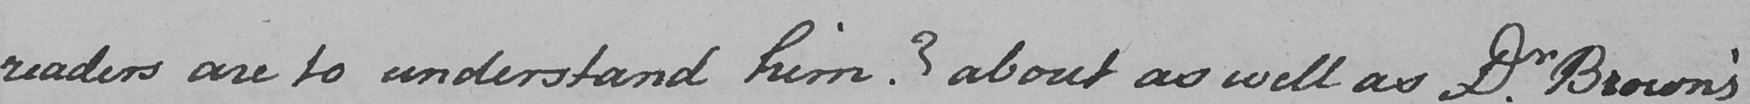Please transcribe the handwritten text in this image. readers are to understand him ?  about as well as Dr . Brown ' s 